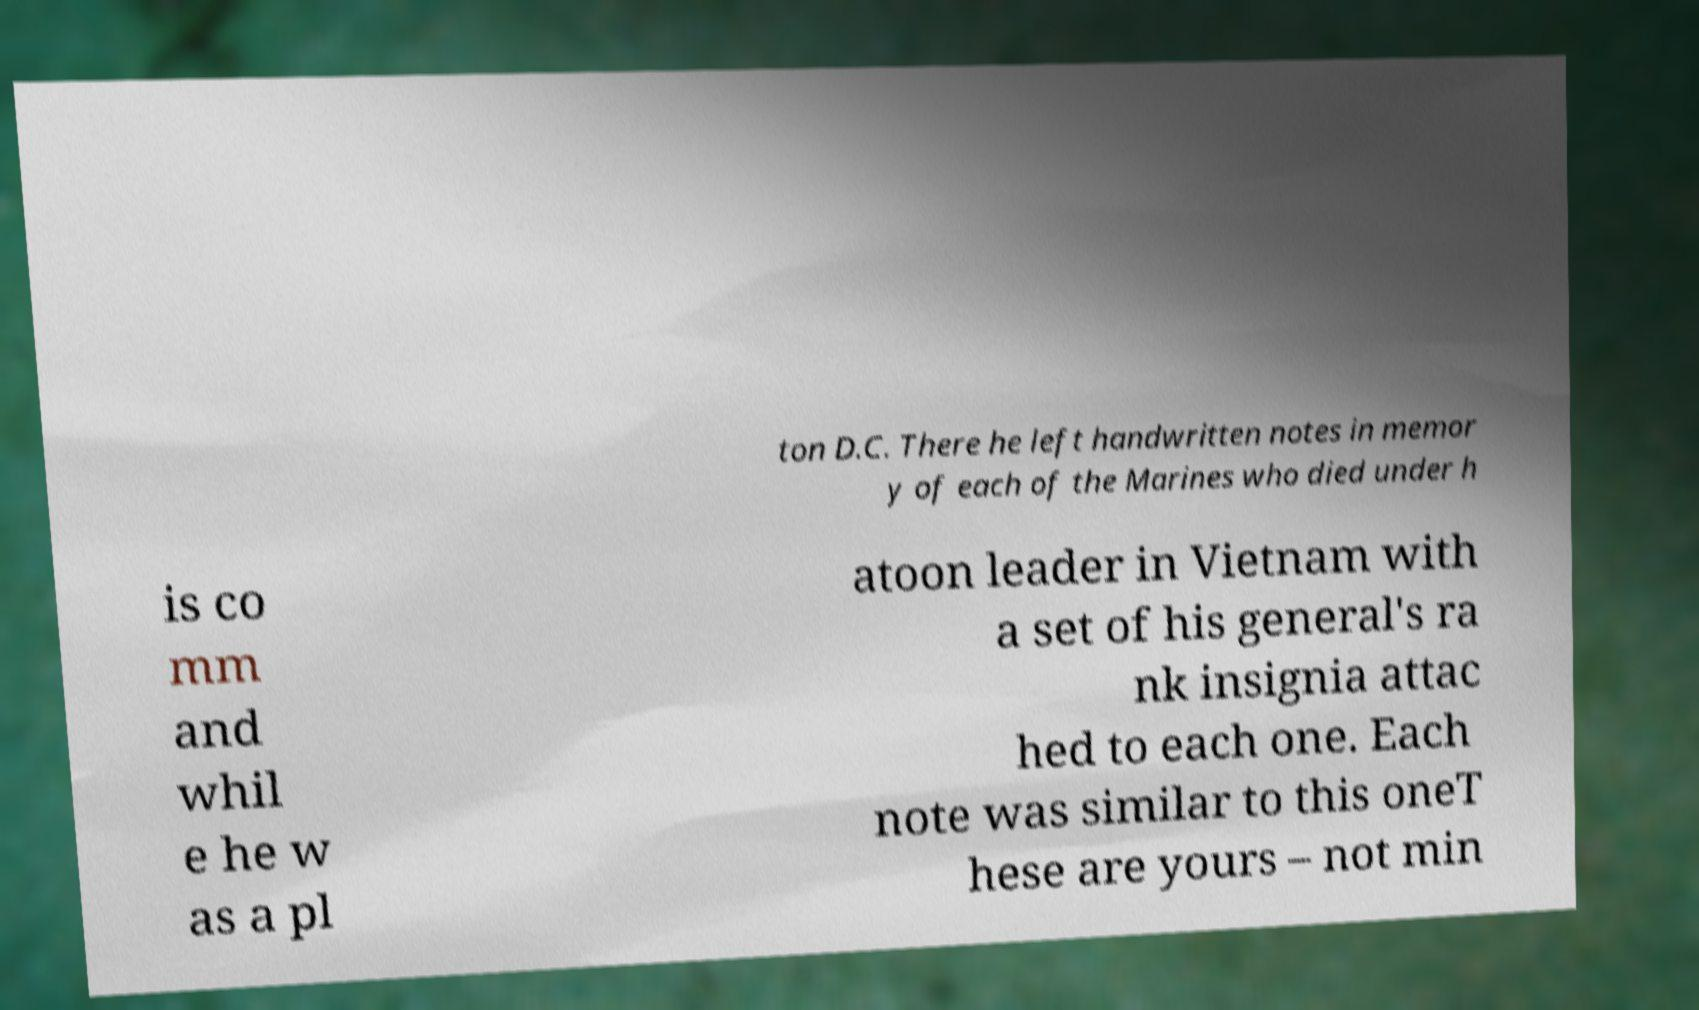Can you accurately transcribe the text from the provided image for me? ton D.C. There he left handwritten notes in memor y of each of the Marines who died under h is co mm and whil e he w as a pl atoon leader in Vietnam with a set of his general's ra nk insignia attac hed to each one. Each note was similar to this oneT hese are yours – not min 